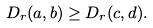<formula> <loc_0><loc_0><loc_500><loc_500>D _ { r } ( a , b ) \geq D _ { r } ( c , d ) .</formula> 